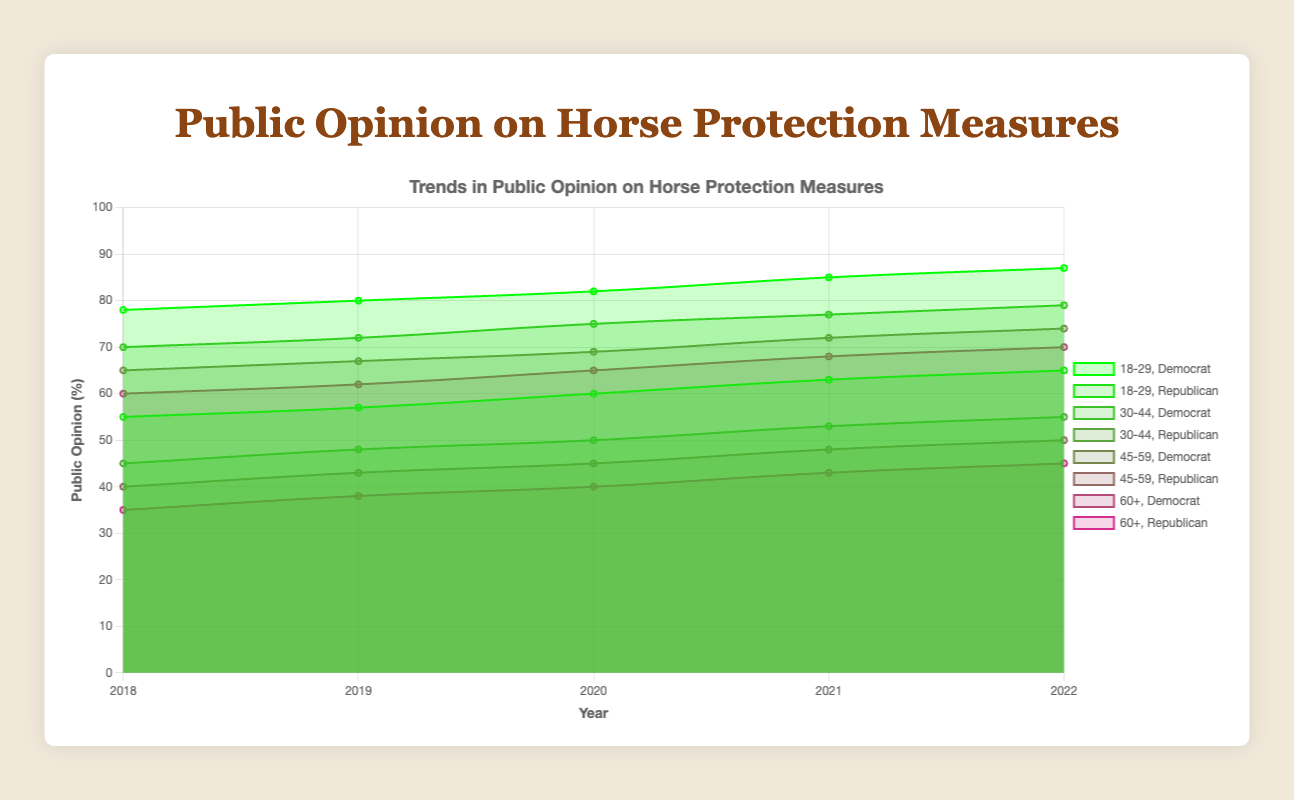What is the title of the chart? The title of the chart is typically displayed at the top of the figure and summarizes the content. Here, it's "Public Opinion on Horse Protection Measures".
Answer: Public Opinion on Horse Protection Measures Which age and political affiliation group shows the highest increase in public opinion from 2018 to 2022? Look at the data points for each group from 2018 to 2022 and calculate the difference. The "18-29, Democrat" group starts at 78 in 2018 and ends at 87 in 2022, which is an increase of 9 points. This is higher than the increases for the other groups.
Answer: 18-29, Democrat What is the lowest public opinion percentage recorded in 2020, and which group does it correspond to? Identify the values for each group in 2020. The lowest value is 40, which corresponds to the "60+, Republican" group.
Answer: 40, 60+, Republican Which age group shows consistent increase in approval rates regardless of political affiliation? Check if all political subgroups within an age group have increasing data points year over year. Both Democrat and Republican subgroups within the "18-29" age group show consistent increases from 2018 to 2022.
Answer: 18-29 How many total data points are plotted on the chart? Each of the 8 groups has 5 data points (one for each year from 2018 to 2022). Therefore, the total number of data points is 8 groups * 5 data points = 40.
Answer: 40 Is the public opinion for horse protection measures higher in 2022 for Democrats or Republicans across all age groups? Compare the 2022 values for each age group between Democrats and Republicans. Every Democrat group has a higher value (87, 79, 74, 70) compared to the Republican group (65, 55, 50, 45) in their respective age ranges.
Answer: Democrats Which group shows the smallest range (difference between highest and lowest values) in the given period? Compute the range for each group by subtracting the lowest value from the highest. The smallest range belongs to the "45-59, Republican" group, with values increasing from 40 to 50, giving a range of 10.
Answer: 45-59, Republican How does the trend in public opinion for the "60+, Democrat" group compare to the "60+, Republican" group over the years? Analyze the slope of each group's line. The "60+, Democrat" group shows a steady increase from 60 to 70, while the "60+, Republican" group also shows a steady increase from 35 to 45, but the Democrat group has higher values throughout.
Answer: 60+, Democrat shows a steady increase but at higher values What is the average public opinion percentage for the "30-44, Democrat" group over the period 2018-2022? Sum the values for this group (70 + 72 + 75 + 77 + 79) and divide by the number of data points (5). The average is (70 + 72 + 75 + 77 + 79) / 5 = 373 / 5 = 74.6
Answer: 74.6 What is the trend direction for the "30-44, Republican" group from 2018 to 2022? Observe the changes in the data points for this group over time. The values go from 45 in 2018 to 55 in 2022, showing a consistently upward trend.
Answer: Upward 